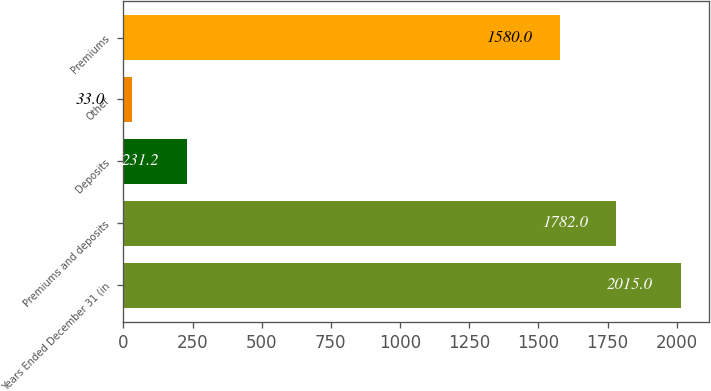<chart> <loc_0><loc_0><loc_500><loc_500><bar_chart><fcel>Years Ended December 31 (in<fcel>Premiums and deposits<fcel>Deposits<fcel>Other<fcel>Premiums<nl><fcel>2015<fcel>1782<fcel>231.2<fcel>33<fcel>1580<nl></chart> 